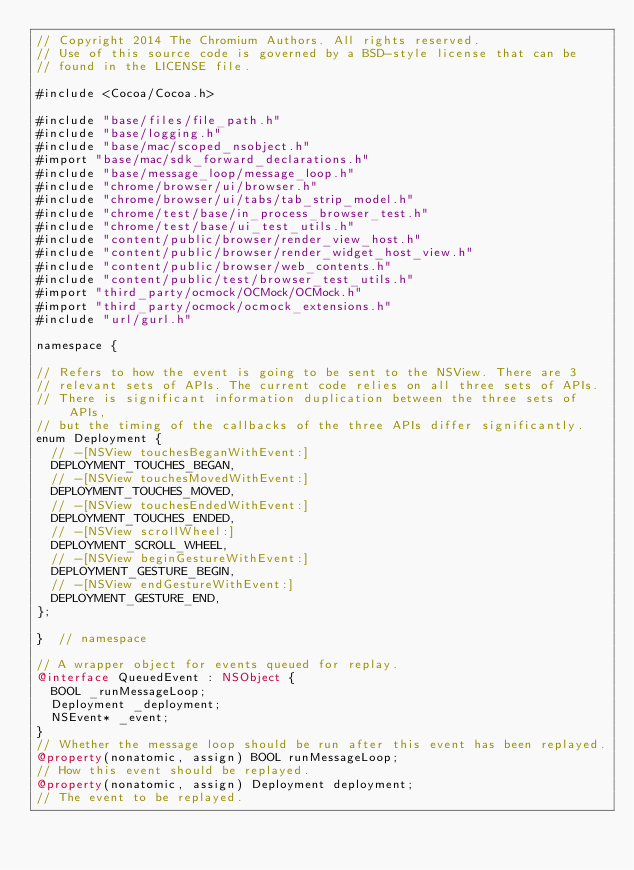<code> <loc_0><loc_0><loc_500><loc_500><_ObjectiveC_>// Copyright 2014 The Chromium Authors. All rights reserved.
// Use of this source code is governed by a BSD-style license that can be
// found in the LICENSE file.

#include <Cocoa/Cocoa.h>

#include "base/files/file_path.h"
#include "base/logging.h"
#include "base/mac/scoped_nsobject.h"
#import "base/mac/sdk_forward_declarations.h"
#include "base/message_loop/message_loop.h"
#include "chrome/browser/ui/browser.h"
#include "chrome/browser/ui/tabs/tab_strip_model.h"
#include "chrome/test/base/in_process_browser_test.h"
#include "chrome/test/base/ui_test_utils.h"
#include "content/public/browser/render_view_host.h"
#include "content/public/browser/render_widget_host_view.h"
#include "content/public/browser/web_contents.h"
#include "content/public/test/browser_test_utils.h"
#import "third_party/ocmock/OCMock/OCMock.h"
#import "third_party/ocmock/ocmock_extensions.h"
#include "url/gurl.h"

namespace {

// Refers to how the event is going to be sent to the NSView. There are 3
// relevant sets of APIs. The current code relies on all three sets of APIs.
// There is significant information duplication between the three sets of APIs,
// but the timing of the callbacks of the three APIs differ significantly.
enum Deployment {
  // -[NSView touchesBeganWithEvent:]
  DEPLOYMENT_TOUCHES_BEGAN,
  // -[NSView touchesMovedWithEvent:]
  DEPLOYMENT_TOUCHES_MOVED,
  // -[NSView touchesEndedWithEvent:]
  DEPLOYMENT_TOUCHES_ENDED,
  // -[NSView scrollWheel:]
  DEPLOYMENT_SCROLL_WHEEL,
  // -[NSView beginGestureWithEvent:]
  DEPLOYMENT_GESTURE_BEGIN,
  // -[NSView endGestureWithEvent:]
  DEPLOYMENT_GESTURE_END,
};

}  // namespace

// A wrapper object for events queued for replay.
@interface QueuedEvent : NSObject {
  BOOL _runMessageLoop;
  Deployment _deployment;
  NSEvent* _event;
}
// Whether the message loop should be run after this event has been replayed.
@property(nonatomic, assign) BOOL runMessageLoop;
// How this event should be replayed.
@property(nonatomic, assign) Deployment deployment;
// The event to be replayed.</code> 